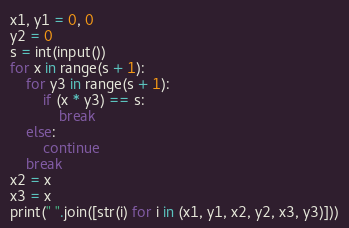Convert code to text. <code><loc_0><loc_0><loc_500><loc_500><_Python_>x1, y1 = 0, 0
y2 = 0
s = int(input())
for x in range(s + 1):
    for y3 in range(s + 1):
        if (x * y3) == s:
            break
    else:
        continue
    break
x2 = x
x3 = x
print(" ".join([str(i) for i in (x1, y1, x2, y2, x3, y3)]))</code> 